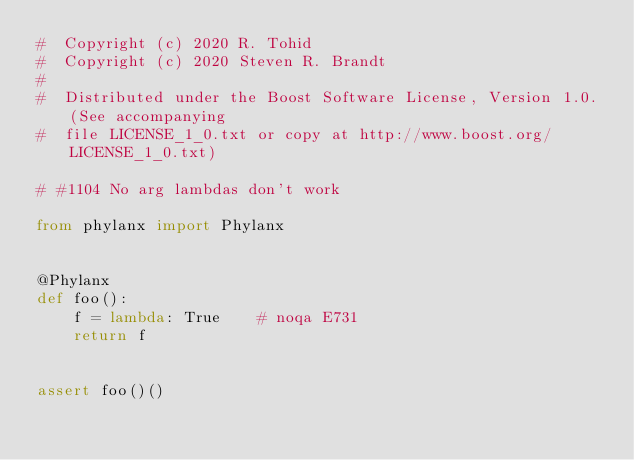Convert code to text. <code><loc_0><loc_0><loc_500><loc_500><_Python_>#  Copyright (c) 2020 R. Tohid
#  Copyright (c) 2020 Steven R. Brandt
#
#  Distributed under the Boost Software License, Version 1.0. (See accompanying
#  file LICENSE_1_0.txt or copy at http://www.boost.org/LICENSE_1_0.txt)

# #1104 No arg lambdas don't work

from phylanx import Phylanx


@Phylanx
def foo():
    f = lambda: True    # noqa E731
    return f


assert foo()()
</code> 